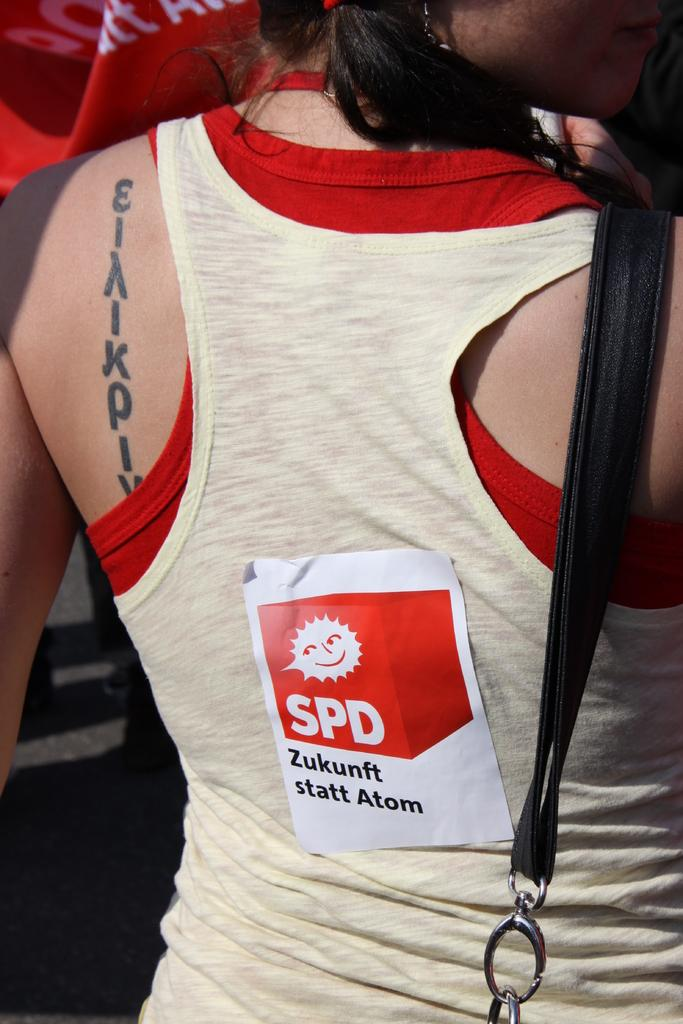Who is present in the image? There is a woman in the image. What is the woman wearing? The woman is wearing a bag. Are there any additional details about the woman's clothing? Yes, there is a sticker on her dress. What type of joke is the fireman telling in the image? There is no fireman present in the image, nor is there any indication of a joke being told. 